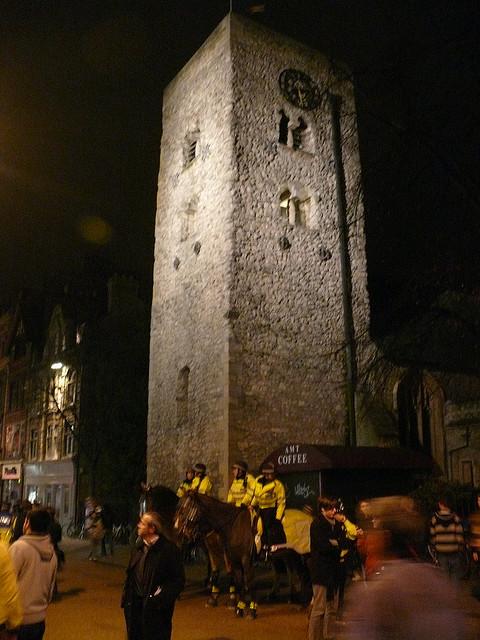How many police are on horseback?
Short answer required. 4. Is it night?
Short answer required. Yes. Why is there a no parking notice?
Concise answer only. No. What year might the building have been made approximately?
Answer briefly. 1800. 